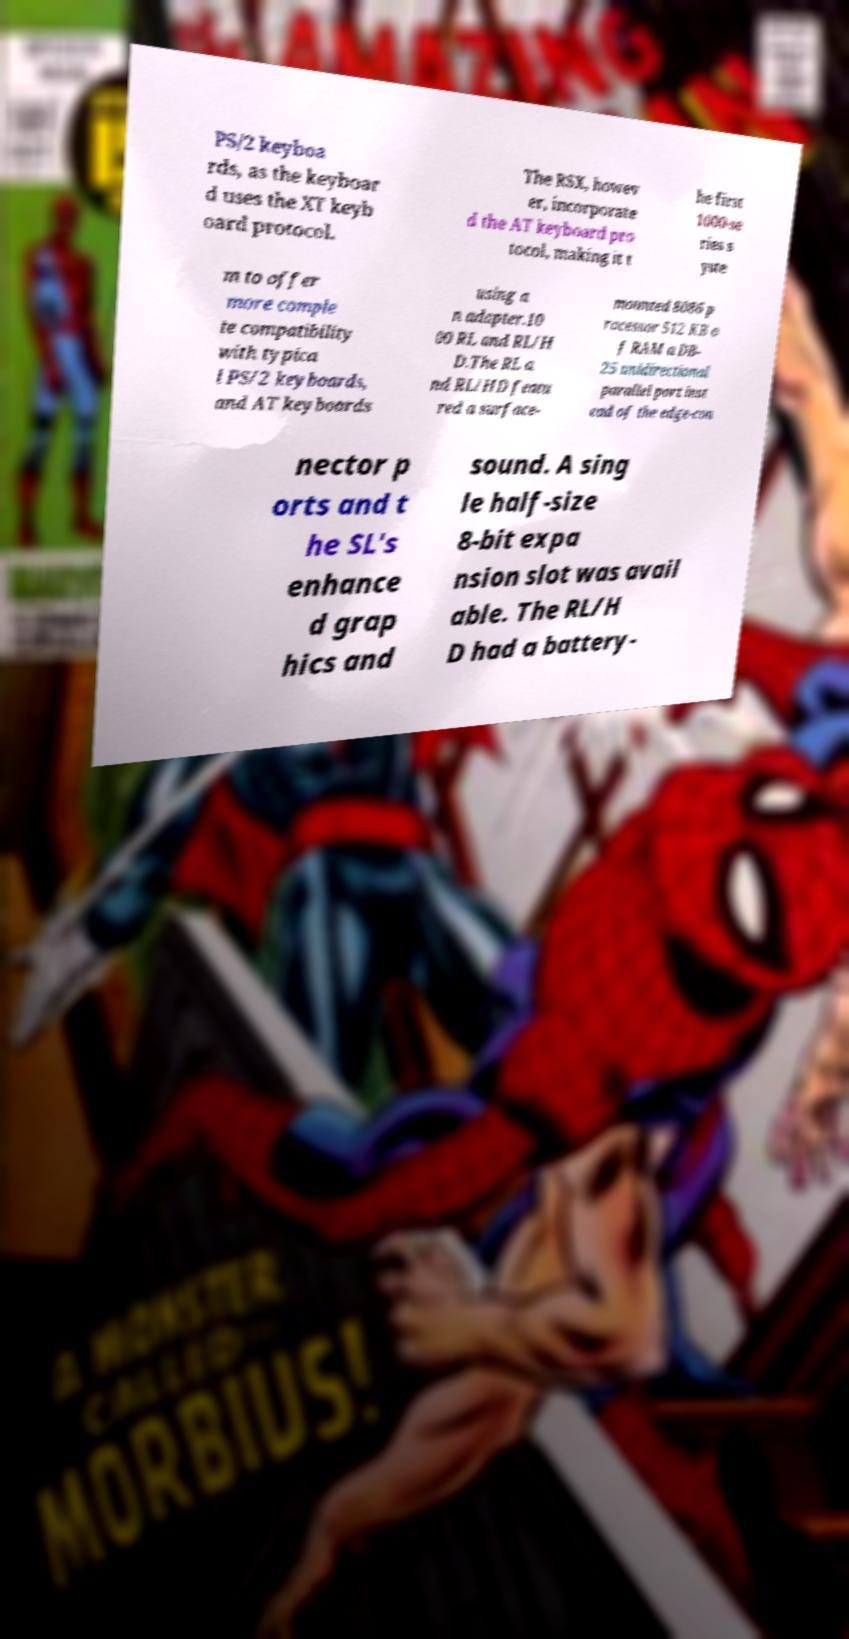Please identify and transcribe the text found in this image. PS/2 keyboa rds, as the keyboar d uses the XT keyb oard protocol. The RSX, howev er, incorporate d the AT keyboard pro tocol, making it t he first 1000-se ries s yste m to offer more comple te compatibility with typica l PS/2 keyboards, and AT keyboards using a n adapter.10 00 RL and RL/H D.The RL a nd RL/HD featu red a surface- mounted 8086 p rocessor 512 KB o f RAM a DB- 25 unidirectional parallel port inst ead of the edge-con nector p orts and t he SL's enhance d grap hics and sound. A sing le half-size 8-bit expa nsion slot was avail able. The RL/H D had a battery- 